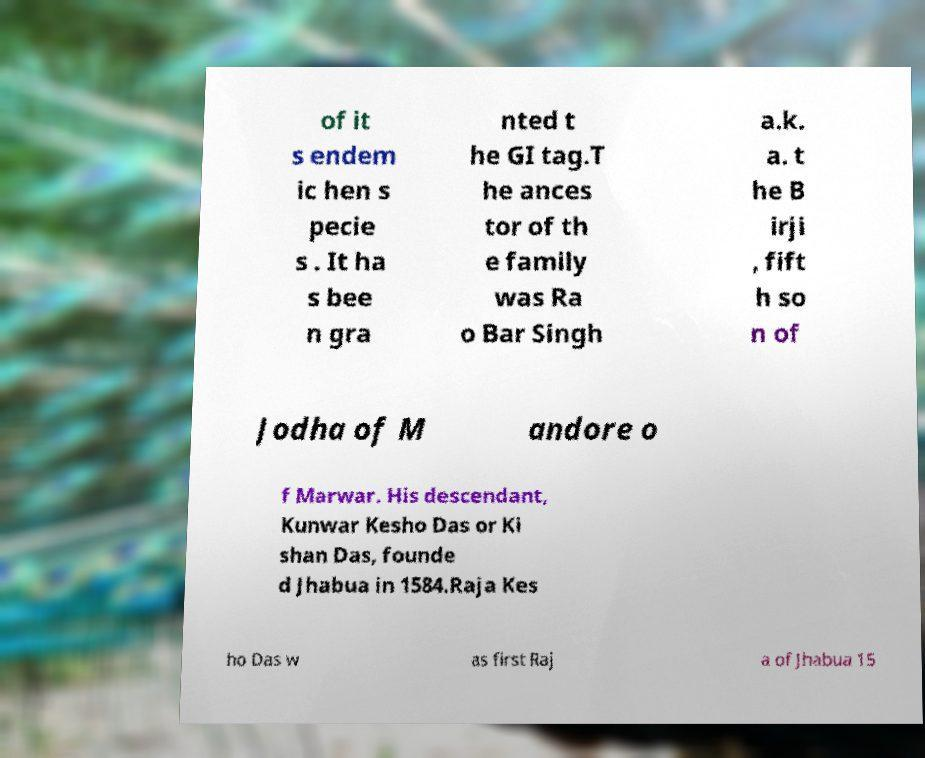Could you assist in decoding the text presented in this image and type it out clearly? of it s endem ic hen s pecie s . It ha s bee n gra nted t he GI tag.T he ances tor of th e family was Ra o Bar Singh a.k. a. t he B irji , fift h so n of Jodha of M andore o f Marwar. His descendant, Kunwar Kesho Das or Ki shan Das, founde d Jhabua in 1584.Raja Kes ho Das w as first Raj a of Jhabua 15 